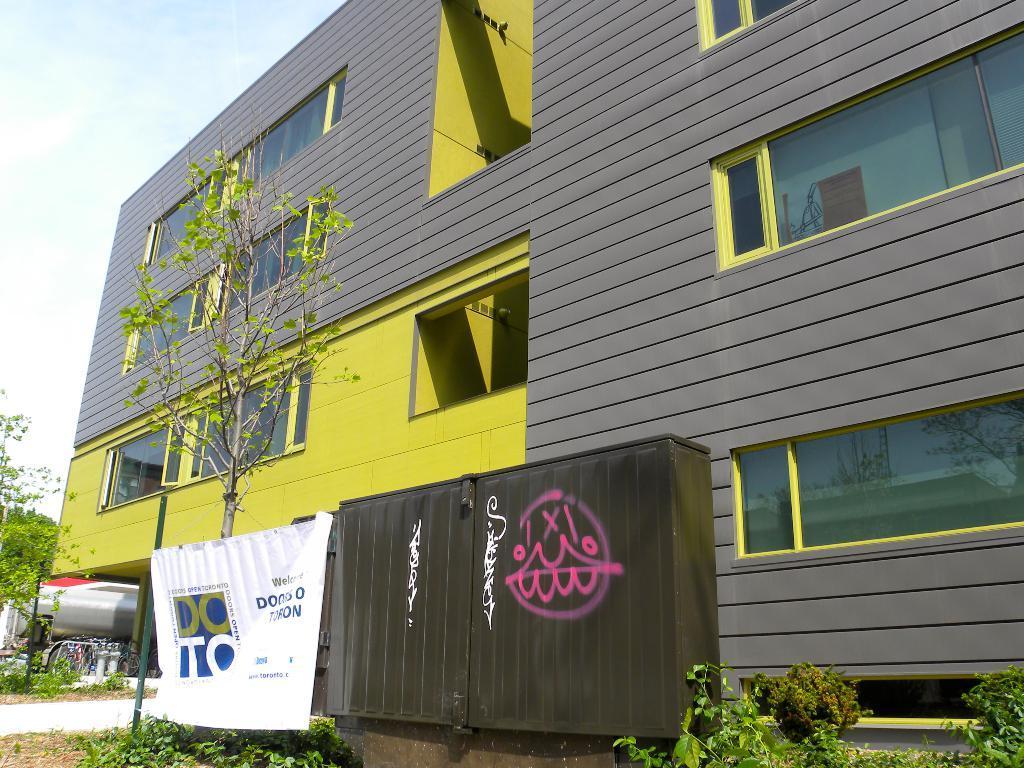Describe this image in one or two sentences. In this picture I can see a building and I can see trees and plants and I can see a banner with some text and a metal box and I can see cloudy sky. 